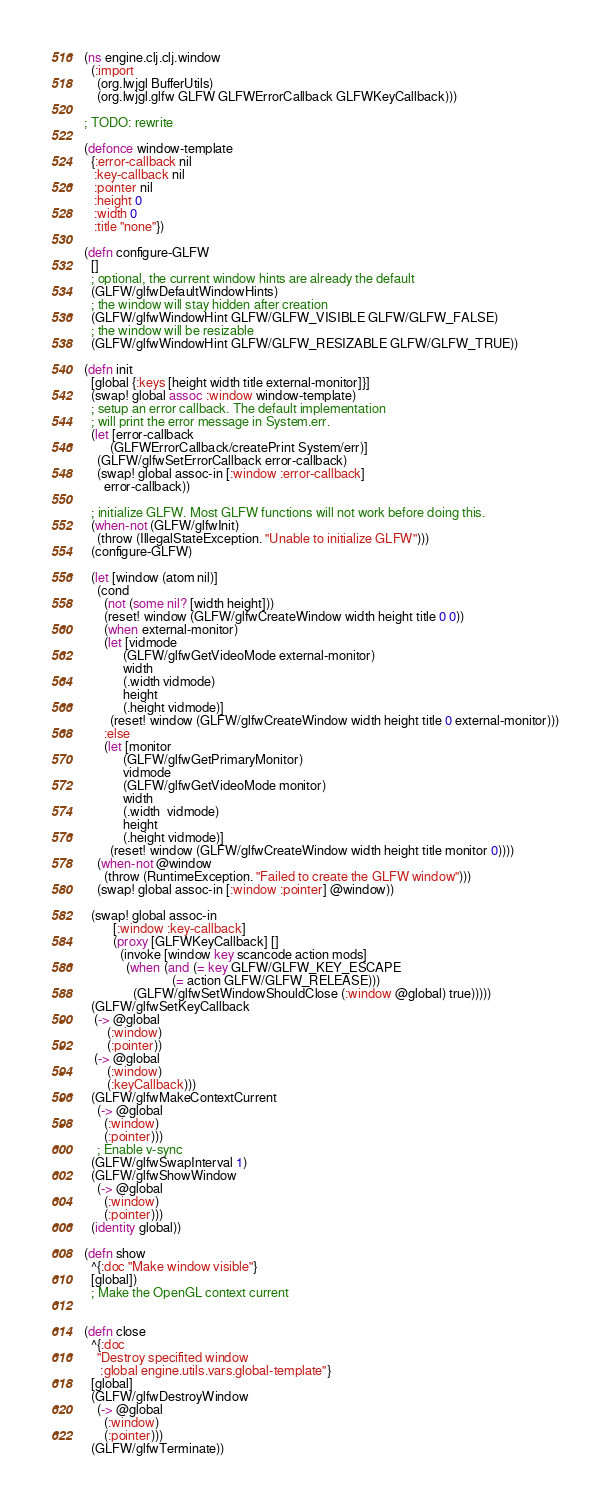<code> <loc_0><loc_0><loc_500><loc_500><_Clojure_>(ns engine.clj.clj.window
  (:import
    (org.lwjgl BufferUtils)
    (org.lwjgl.glfw GLFW GLFWErrorCallback GLFWKeyCallback)))

; TODO: rewrite

(defonce window-template
  {:error-callback nil
   :key-callback nil
   :pointer nil
   :height 0
   :width 0
   :title "none"})

(defn configure-GLFW
  []
  ; optional, the current window hints are already the default
  (GLFW/glfwDefaultWindowHints)
  ; the window will stay hidden after creation
  (GLFW/glfwWindowHint GLFW/GLFW_VISIBLE GLFW/GLFW_FALSE)
  ; the window will be resizable
  (GLFW/glfwWindowHint GLFW/GLFW_RESIZABLE GLFW/GLFW_TRUE))

(defn init
  [global {:keys [height width title external-monitor]}]
  (swap! global assoc :window window-template)
  ; setup an error callback. The default implementation
  ; will print the error message in System.err.
  (let [error-callback
        (GLFWErrorCallback/createPrint System/err)]
    (GLFW/glfwSetErrorCallback error-callback)
    (swap! global assoc-in [:window :error-callback]
      error-callback))

  ; initialize GLFW. Most GLFW functions will not work before doing this.
  (when-not (GLFW/glfwInit)
    (throw (IllegalStateException. "Unable to initialize GLFW")))
  (configure-GLFW)

  (let [window (atom nil)]
    (cond
      (not (some nil? [width height]))
      (reset! window (GLFW/glfwCreateWindow width height title 0 0))
      (when external-monitor)
      (let [vidmode
            (GLFW/glfwGetVideoMode external-monitor)
            width
            (.width vidmode)
            height
            (.height vidmode)]
        (reset! window (GLFW/glfwCreateWindow width height title 0 external-monitor)))
      :else
      (let [monitor
            (GLFW/glfwGetPrimaryMonitor)
            vidmode
            (GLFW/glfwGetVideoMode monitor)
            width
            (.width  vidmode)
            height
            (.height vidmode)]
        (reset! window (GLFW/glfwCreateWindow width height title monitor 0))))
    (when-not @window
      (throw (RuntimeException. "Failed to create the GLFW window")))
    (swap! global assoc-in [:window :pointer] @window))

  (swap! global assoc-in
         [:window :key-callback]
         (proxy [GLFWKeyCallback] []
           (invoke [window key scancode action mods]
             (when (and (= key GLFW/GLFW_KEY_ESCAPE
                           (= action GLFW/GLFW_RELEASE)))
               (GLFW/glfwSetWindowShouldClose (:window @global) true)))))
  (GLFW/glfwSetKeyCallback
   (-> @global
       (:window)
       (:pointer))
   (-> @global
       (:window)
       (:keyCallback)))
  (GLFW/glfwMakeContextCurrent
    (-> @global
      (:window)
      (:pointer)))
    ; Enable v-sync
  (GLFW/glfwSwapInterval 1)
  (GLFW/glfwShowWindow
    (-> @global
      (:window)
      (:pointer)))
  (identity global))

(defn show
  ^{:doc "Make window visible"}
  [global])
  ; Make the OpenGL context current


(defn close
  ^{:doc
    "Destroy specifited window
     :global engine.utils.vars.global-template"}
  [global]
  (GLFW/glfwDestroyWindow
    (-> @global
      (:window)
      (:pointer)))
  (GLFW/glfwTerminate))

</code> 